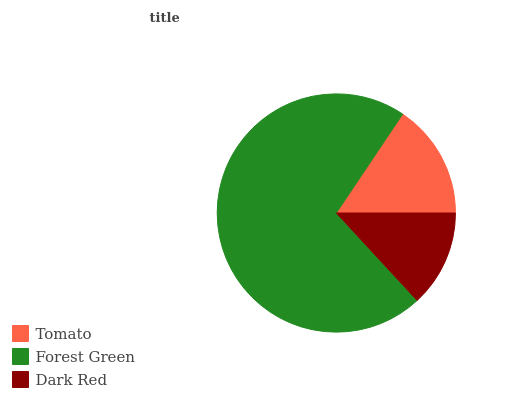Is Dark Red the minimum?
Answer yes or no. Yes. Is Forest Green the maximum?
Answer yes or no. Yes. Is Forest Green the minimum?
Answer yes or no. No. Is Dark Red the maximum?
Answer yes or no. No. Is Forest Green greater than Dark Red?
Answer yes or no. Yes. Is Dark Red less than Forest Green?
Answer yes or no. Yes. Is Dark Red greater than Forest Green?
Answer yes or no. No. Is Forest Green less than Dark Red?
Answer yes or no. No. Is Tomato the high median?
Answer yes or no. Yes. Is Tomato the low median?
Answer yes or no. Yes. Is Forest Green the high median?
Answer yes or no. No. Is Dark Red the low median?
Answer yes or no. No. 